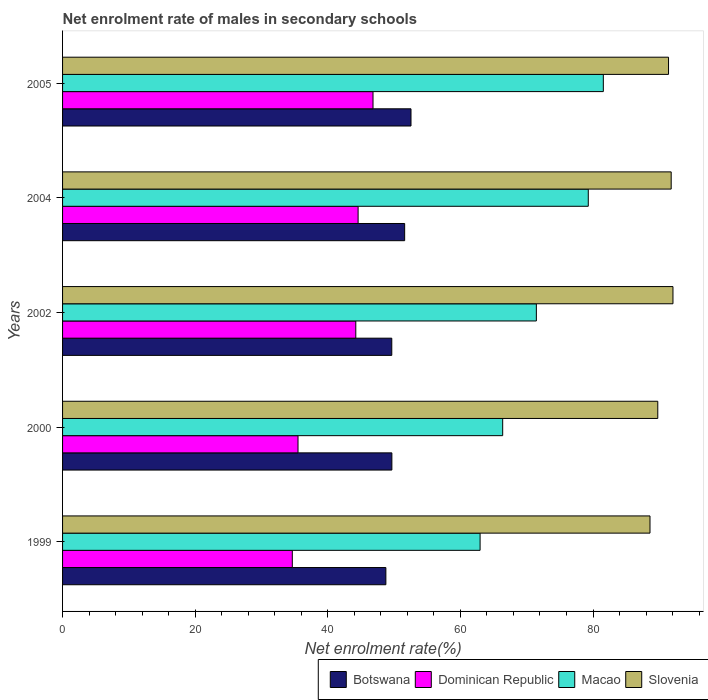Are the number of bars per tick equal to the number of legend labels?
Keep it short and to the point. Yes. How many bars are there on the 3rd tick from the top?
Give a very brief answer. 4. How many bars are there on the 2nd tick from the bottom?
Your response must be concise. 4. What is the label of the 1st group of bars from the top?
Offer a terse response. 2005. In how many cases, is the number of bars for a given year not equal to the number of legend labels?
Ensure brevity in your answer.  0. What is the net enrolment rate of males in secondary schools in Dominican Republic in 1999?
Provide a succinct answer. 34.65. Across all years, what is the maximum net enrolment rate of males in secondary schools in Macao?
Keep it short and to the point. 81.56. Across all years, what is the minimum net enrolment rate of males in secondary schools in Dominican Republic?
Provide a short and direct response. 34.65. In which year was the net enrolment rate of males in secondary schools in Slovenia minimum?
Your response must be concise. 1999. What is the total net enrolment rate of males in secondary schools in Dominican Republic in the graph?
Provide a succinct answer. 205.78. What is the difference between the net enrolment rate of males in secondary schools in Botswana in 2002 and that in 2004?
Your response must be concise. -1.94. What is the difference between the net enrolment rate of males in secondary schools in Botswana in 2000 and the net enrolment rate of males in secondary schools in Dominican Republic in 2002?
Provide a short and direct response. 5.44. What is the average net enrolment rate of males in secondary schools in Macao per year?
Your response must be concise. 72.33. In the year 2000, what is the difference between the net enrolment rate of males in secondary schools in Dominican Republic and net enrolment rate of males in secondary schools in Slovenia?
Your response must be concise. -54.26. What is the ratio of the net enrolment rate of males in secondary schools in Botswana in 1999 to that in 2000?
Your answer should be very brief. 0.98. Is the net enrolment rate of males in secondary schools in Macao in 2004 less than that in 2005?
Offer a very short reply. Yes. What is the difference between the highest and the second highest net enrolment rate of males in secondary schools in Slovenia?
Make the answer very short. 0.27. What is the difference between the highest and the lowest net enrolment rate of males in secondary schools in Slovenia?
Make the answer very short. 3.46. Is the sum of the net enrolment rate of males in secondary schools in Slovenia in 2004 and 2005 greater than the maximum net enrolment rate of males in secondary schools in Macao across all years?
Provide a succinct answer. Yes. What does the 2nd bar from the top in 2004 represents?
Provide a short and direct response. Macao. What does the 4th bar from the bottom in 2002 represents?
Keep it short and to the point. Slovenia. Are all the bars in the graph horizontal?
Your answer should be very brief. Yes. How many years are there in the graph?
Provide a succinct answer. 5. What is the difference between two consecutive major ticks on the X-axis?
Offer a very short reply. 20. Does the graph contain any zero values?
Your answer should be very brief. No. Where does the legend appear in the graph?
Give a very brief answer. Bottom right. What is the title of the graph?
Offer a very short reply. Net enrolment rate of males in secondary schools. What is the label or title of the X-axis?
Provide a short and direct response. Net enrolment rate(%). What is the label or title of the Y-axis?
Your response must be concise. Years. What is the Net enrolment rate(%) in Botswana in 1999?
Keep it short and to the point. 48.76. What is the Net enrolment rate(%) in Dominican Republic in 1999?
Ensure brevity in your answer.  34.65. What is the Net enrolment rate(%) of Macao in 1999?
Your answer should be compact. 62.97. What is the Net enrolment rate(%) of Slovenia in 1999?
Provide a short and direct response. 88.6. What is the Net enrolment rate(%) in Botswana in 2000?
Give a very brief answer. 49.67. What is the Net enrolment rate(%) of Dominican Republic in 2000?
Keep it short and to the point. 35.51. What is the Net enrolment rate(%) of Macao in 2000?
Make the answer very short. 66.38. What is the Net enrolment rate(%) in Slovenia in 2000?
Your response must be concise. 89.77. What is the Net enrolment rate(%) of Botswana in 2002?
Your answer should be very brief. 49.65. What is the Net enrolment rate(%) in Dominican Republic in 2002?
Your answer should be very brief. 44.22. What is the Net enrolment rate(%) of Macao in 2002?
Your response must be concise. 71.46. What is the Net enrolment rate(%) in Slovenia in 2002?
Provide a succinct answer. 92.06. What is the Net enrolment rate(%) of Botswana in 2004?
Keep it short and to the point. 51.59. What is the Net enrolment rate(%) of Dominican Republic in 2004?
Provide a short and direct response. 44.57. What is the Net enrolment rate(%) of Macao in 2004?
Ensure brevity in your answer.  79.29. What is the Net enrolment rate(%) in Slovenia in 2004?
Give a very brief answer. 91.79. What is the Net enrolment rate(%) of Botswana in 2005?
Offer a terse response. 52.55. What is the Net enrolment rate(%) in Dominican Republic in 2005?
Your response must be concise. 46.82. What is the Net enrolment rate(%) in Macao in 2005?
Your response must be concise. 81.56. What is the Net enrolment rate(%) in Slovenia in 2005?
Ensure brevity in your answer.  91.39. Across all years, what is the maximum Net enrolment rate(%) of Botswana?
Offer a terse response. 52.55. Across all years, what is the maximum Net enrolment rate(%) in Dominican Republic?
Provide a short and direct response. 46.82. Across all years, what is the maximum Net enrolment rate(%) of Macao?
Make the answer very short. 81.56. Across all years, what is the maximum Net enrolment rate(%) in Slovenia?
Keep it short and to the point. 92.06. Across all years, what is the minimum Net enrolment rate(%) of Botswana?
Make the answer very short. 48.76. Across all years, what is the minimum Net enrolment rate(%) of Dominican Republic?
Ensure brevity in your answer.  34.65. Across all years, what is the minimum Net enrolment rate(%) in Macao?
Make the answer very short. 62.97. Across all years, what is the minimum Net enrolment rate(%) of Slovenia?
Ensure brevity in your answer.  88.6. What is the total Net enrolment rate(%) of Botswana in the graph?
Provide a succinct answer. 252.22. What is the total Net enrolment rate(%) in Dominican Republic in the graph?
Offer a very short reply. 205.78. What is the total Net enrolment rate(%) of Macao in the graph?
Your response must be concise. 361.65. What is the total Net enrolment rate(%) of Slovenia in the graph?
Provide a short and direct response. 453.61. What is the difference between the Net enrolment rate(%) of Botswana in 1999 and that in 2000?
Offer a terse response. -0.9. What is the difference between the Net enrolment rate(%) of Dominican Republic in 1999 and that in 2000?
Your answer should be compact. -0.86. What is the difference between the Net enrolment rate(%) in Macao in 1999 and that in 2000?
Offer a very short reply. -3.41. What is the difference between the Net enrolment rate(%) in Slovenia in 1999 and that in 2000?
Provide a succinct answer. -1.17. What is the difference between the Net enrolment rate(%) of Botswana in 1999 and that in 2002?
Your response must be concise. -0.89. What is the difference between the Net enrolment rate(%) in Dominican Republic in 1999 and that in 2002?
Your response must be concise. -9.57. What is the difference between the Net enrolment rate(%) in Macao in 1999 and that in 2002?
Your answer should be compact. -8.49. What is the difference between the Net enrolment rate(%) of Slovenia in 1999 and that in 2002?
Provide a succinct answer. -3.46. What is the difference between the Net enrolment rate(%) of Botswana in 1999 and that in 2004?
Ensure brevity in your answer.  -2.83. What is the difference between the Net enrolment rate(%) of Dominican Republic in 1999 and that in 2004?
Keep it short and to the point. -9.92. What is the difference between the Net enrolment rate(%) in Macao in 1999 and that in 2004?
Provide a succinct answer. -16.32. What is the difference between the Net enrolment rate(%) in Slovenia in 1999 and that in 2004?
Keep it short and to the point. -3.2. What is the difference between the Net enrolment rate(%) in Botswana in 1999 and that in 2005?
Give a very brief answer. -3.79. What is the difference between the Net enrolment rate(%) in Dominican Republic in 1999 and that in 2005?
Give a very brief answer. -12.17. What is the difference between the Net enrolment rate(%) in Macao in 1999 and that in 2005?
Offer a very short reply. -18.59. What is the difference between the Net enrolment rate(%) in Slovenia in 1999 and that in 2005?
Give a very brief answer. -2.79. What is the difference between the Net enrolment rate(%) in Botswana in 2000 and that in 2002?
Give a very brief answer. 0.01. What is the difference between the Net enrolment rate(%) of Dominican Republic in 2000 and that in 2002?
Provide a short and direct response. -8.71. What is the difference between the Net enrolment rate(%) in Macao in 2000 and that in 2002?
Keep it short and to the point. -5.08. What is the difference between the Net enrolment rate(%) of Slovenia in 2000 and that in 2002?
Your response must be concise. -2.29. What is the difference between the Net enrolment rate(%) of Botswana in 2000 and that in 2004?
Offer a terse response. -1.93. What is the difference between the Net enrolment rate(%) in Dominican Republic in 2000 and that in 2004?
Give a very brief answer. -9.06. What is the difference between the Net enrolment rate(%) of Macao in 2000 and that in 2004?
Give a very brief answer. -12.91. What is the difference between the Net enrolment rate(%) of Slovenia in 2000 and that in 2004?
Your answer should be very brief. -2.02. What is the difference between the Net enrolment rate(%) of Botswana in 2000 and that in 2005?
Keep it short and to the point. -2.89. What is the difference between the Net enrolment rate(%) in Dominican Republic in 2000 and that in 2005?
Ensure brevity in your answer.  -11.31. What is the difference between the Net enrolment rate(%) of Macao in 2000 and that in 2005?
Your answer should be very brief. -15.18. What is the difference between the Net enrolment rate(%) in Slovenia in 2000 and that in 2005?
Give a very brief answer. -1.62. What is the difference between the Net enrolment rate(%) in Botswana in 2002 and that in 2004?
Make the answer very short. -1.94. What is the difference between the Net enrolment rate(%) in Dominican Republic in 2002 and that in 2004?
Provide a short and direct response. -0.35. What is the difference between the Net enrolment rate(%) of Macao in 2002 and that in 2004?
Your response must be concise. -7.83. What is the difference between the Net enrolment rate(%) in Slovenia in 2002 and that in 2004?
Provide a short and direct response. 0.27. What is the difference between the Net enrolment rate(%) of Botswana in 2002 and that in 2005?
Offer a terse response. -2.9. What is the difference between the Net enrolment rate(%) of Dominican Republic in 2002 and that in 2005?
Your response must be concise. -2.6. What is the difference between the Net enrolment rate(%) of Macao in 2002 and that in 2005?
Give a very brief answer. -10.1. What is the difference between the Net enrolment rate(%) in Slovenia in 2002 and that in 2005?
Keep it short and to the point. 0.67. What is the difference between the Net enrolment rate(%) of Botswana in 2004 and that in 2005?
Offer a very short reply. -0.96. What is the difference between the Net enrolment rate(%) in Dominican Republic in 2004 and that in 2005?
Your answer should be compact. -2.25. What is the difference between the Net enrolment rate(%) of Macao in 2004 and that in 2005?
Offer a very short reply. -2.27. What is the difference between the Net enrolment rate(%) of Slovenia in 2004 and that in 2005?
Make the answer very short. 0.4. What is the difference between the Net enrolment rate(%) in Botswana in 1999 and the Net enrolment rate(%) in Dominican Republic in 2000?
Your answer should be very brief. 13.25. What is the difference between the Net enrolment rate(%) of Botswana in 1999 and the Net enrolment rate(%) of Macao in 2000?
Make the answer very short. -17.62. What is the difference between the Net enrolment rate(%) in Botswana in 1999 and the Net enrolment rate(%) in Slovenia in 2000?
Your response must be concise. -41.01. What is the difference between the Net enrolment rate(%) in Dominican Republic in 1999 and the Net enrolment rate(%) in Macao in 2000?
Make the answer very short. -31.73. What is the difference between the Net enrolment rate(%) of Dominican Republic in 1999 and the Net enrolment rate(%) of Slovenia in 2000?
Your response must be concise. -55.12. What is the difference between the Net enrolment rate(%) of Macao in 1999 and the Net enrolment rate(%) of Slovenia in 2000?
Make the answer very short. -26.8. What is the difference between the Net enrolment rate(%) in Botswana in 1999 and the Net enrolment rate(%) in Dominican Republic in 2002?
Provide a succinct answer. 4.54. What is the difference between the Net enrolment rate(%) in Botswana in 1999 and the Net enrolment rate(%) in Macao in 2002?
Offer a very short reply. -22.7. What is the difference between the Net enrolment rate(%) of Botswana in 1999 and the Net enrolment rate(%) of Slovenia in 2002?
Your answer should be very brief. -43.3. What is the difference between the Net enrolment rate(%) in Dominican Republic in 1999 and the Net enrolment rate(%) in Macao in 2002?
Offer a terse response. -36.81. What is the difference between the Net enrolment rate(%) of Dominican Republic in 1999 and the Net enrolment rate(%) of Slovenia in 2002?
Make the answer very short. -57.41. What is the difference between the Net enrolment rate(%) of Macao in 1999 and the Net enrolment rate(%) of Slovenia in 2002?
Your answer should be compact. -29.09. What is the difference between the Net enrolment rate(%) of Botswana in 1999 and the Net enrolment rate(%) of Dominican Republic in 2004?
Offer a very short reply. 4.19. What is the difference between the Net enrolment rate(%) in Botswana in 1999 and the Net enrolment rate(%) in Macao in 2004?
Your response must be concise. -30.53. What is the difference between the Net enrolment rate(%) of Botswana in 1999 and the Net enrolment rate(%) of Slovenia in 2004?
Ensure brevity in your answer.  -43.03. What is the difference between the Net enrolment rate(%) in Dominican Republic in 1999 and the Net enrolment rate(%) in Macao in 2004?
Offer a very short reply. -44.64. What is the difference between the Net enrolment rate(%) of Dominican Republic in 1999 and the Net enrolment rate(%) of Slovenia in 2004?
Keep it short and to the point. -57.14. What is the difference between the Net enrolment rate(%) in Macao in 1999 and the Net enrolment rate(%) in Slovenia in 2004?
Provide a succinct answer. -28.82. What is the difference between the Net enrolment rate(%) of Botswana in 1999 and the Net enrolment rate(%) of Dominican Republic in 2005?
Keep it short and to the point. 1.94. What is the difference between the Net enrolment rate(%) of Botswana in 1999 and the Net enrolment rate(%) of Macao in 2005?
Give a very brief answer. -32.79. What is the difference between the Net enrolment rate(%) of Botswana in 1999 and the Net enrolment rate(%) of Slovenia in 2005?
Give a very brief answer. -42.63. What is the difference between the Net enrolment rate(%) in Dominican Republic in 1999 and the Net enrolment rate(%) in Macao in 2005?
Provide a succinct answer. -46.91. What is the difference between the Net enrolment rate(%) in Dominican Republic in 1999 and the Net enrolment rate(%) in Slovenia in 2005?
Give a very brief answer. -56.74. What is the difference between the Net enrolment rate(%) of Macao in 1999 and the Net enrolment rate(%) of Slovenia in 2005?
Your answer should be compact. -28.42. What is the difference between the Net enrolment rate(%) of Botswana in 2000 and the Net enrolment rate(%) of Dominican Republic in 2002?
Provide a succinct answer. 5.44. What is the difference between the Net enrolment rate(%) in Botswana in 2000 and the Net enrolment rate(%) in Macao in 2002?
Make the answer very short. -21.79. What is the difference between the Net enrolment rate(%) in Botswana in 2000 and the Net enrolment rate(%) in Slovenia in 2002?
Ensure brevity in your answer.  -42.4. What is the difference between the Net enrolment rate(%) in Dominican Republic in 2000 and the Net enrolment rate(%) in Macao in 2002?
Make the answer very short. -35.95. What is the difference between the Net enrolment rate(%) in Dominican Republic in 2000 and the Net enrolment rate(%) in Slovenia in 2002?
Make the answer very short. -56.55. What is the difference between the Net enrolment rate(%) in Macao in 2000 and the Net enrolment rate(%) in Slovenia in 2002?
Offer a very short reply. -25.68. What is the difference between the Net enrolment rate(%) of Botswana in 2000 and the Net enrolment rate(%) of Dominican Republic in 2004?
Your answer should be very brief. 5.09. What is the difference between the Net enrolment rate(%) of Botswana in 2000 and the Net enrolment rate(%) of Macao in 2004?
Your answer should be very brief. -29.62. What is the difference between the Net enrolment rate(%) of Botswana in 2000 and the Net enrolment rate(%) of Slovenia in 2004?
Ensure brevity in your answer.  -42.13. What is the difference between the Net enrolment rate(%) in Dominican Republic in 2000 and the Net enrolment rate(%) in Macao in 2004?
Your answer should be very brief. -43.78. What is the difference between the Net enrolment rate(%) of Dominican Republic in 2000 and the Net enrolment rate(%) of Slovenia in 2004?
Make the answer very short. -56.28. What is the difference between the Net enrolment rate(%) in Macao in 2000 and the Net enrolment rate(%) in Slovenia in 2004?
Your response must be concise. -25.41. What is the difference between the Net enrolment rate(%) in Botswana in 2000 and the Net enrolment rate(%) in Dominican Republic in 2005?
Keep it short and to the point. 2.84. What is the difference between the Net enrolment rate(%) of Botswana in 2000 and the Net enrolment rate(%) of Macao in 2005?
Provide a short and direct response. -31.89. What is the difference between the Net enrolment rate(%) in Botswana in 2000 and the Net enrolment rate(%) in Slovenia in 2005?
Offer a very short reply. -41.73. What is the difference between the Net enrolment rate(%) of Dominican Republic in 2000 and the Net enrolment rate(%) of Macao in 2005?
Keep it short and to the point. -46.05. What is the difference between the Net enrolment rate(%) in Dominican Republic in 2000 and the Net enrolment rate(%) in Slovenia in 2005?
Give a very brief answer. -55.88. What is the difference between the Net enrolment rate(%) in Macao in 2000 and the Net enrolment rate(%) in Slovenia in 2005?
Keep it short and to the point. -25.01. What is the difference between the Net enrolment rate(%) of Botswana in 2002 and the Net enrolment rate(%) of Dominican Republic in 2004?
Your answer should be very brief. 5.08. What is the difference between the Net enrolment rate(%) of Botswana in 2002 and the Net enrolment rate(%) of Macao in 2004?
Make the answer very short. -29.64. What is the difference between the Net enrolment rate(%) of Botswana in 2002 and the Net enrolment rate(%) of Slovenia in 2004?
Provide a succinct answer. -42.14. What is the difference between the Net enrolment rate(%) of Dominican Republic in 2002 and the Net enrolment rate(%) of Macao in 2004?
Make the answer very short. -35.06. What is the difference between the Net enrolment rate(%) of Dominican Republic in 2002 and the Net enrolment rate(%) of Slovenia in 2004?
Make the answer very short. -47.57. What is the difference between the Net enrolment rate(%) of Macao in 2002 and the Net enrolment rate(%) of Slovenia in 2004?
Give a very brief answer. -20.34. What is the difference between the Net enrolment rate(%) in Botswana in 2002 and the Net enrolment rate(%) in Dominican Republic in 2005?
Keep it short and to the point. 2.83. What is the difference between the Net enrolment rate(%) of Botswana in 2002 and the Net enrolment rate(%) of Macao in 2005?
Your response must be concise. -31.91. What is the difference between the Net enrolment rate(%) of Botswana in 2002 and the Net enrolment rate(%) of Slovenia in 2005?
Your answer should be very brief. -41.74. What is the difference between the Net enrolment rate(%) in Dominican Republic in 2002 and the Net enrolment rate(%) in Macao in 2005?
Your answer should be compact. -37.33. What is the difference between the Net enrolment rate(%) in Dominican Republic in 2002 and the Net enrolment rate(%) in Slovenia in 2005?
Offer a very short reply. -47.17. What is the difference between the Net enrolment rate(%) in Macao in 2002 and the Net enrolment rate(%) in Slovenia in 2005?
Offer a terse response. -19.93. What is the difference between the Net enrolment rate(%) of Botswana in 2004 and the Net enrolment rate(%) of Dominican Republic in 2005?
Ensure brevity in your answer.  4.77. What is the difference between the Net enrolment rate(%) of Botswana in 2004 and the Net enrolment rate(%) of Macao in 2005?
Offer a terse response. -29.96. What is the difference between the Net enrolment rate(%) of Botswana in 2004 and the Net enrolment rate(%) of Slovenia in 2005?
Keep it short and to the point. -39.8. What is the difference between the Net enrolment rate(%) of Dominican Republic in 2004 and the Net enrolment rate(%) of Macao in 2005?
Offer a very short reply. -36.98. What is the difference between the Net enrolment rate(%) in Dominican Republic in 2004 and the Net enrolment rate(%) in Slovenia in 2005?
Provide a short and direct response. -46.82. What is the difference between the Net enrolment rate(%) of Macao in 2004 and the Net enrolment rate(%) of Slovenia in 2005?
Your answer should be very brief. -12.1. What is the average Net enrolment rate(%) of Botswana per year?
Give a very brief answer. 50.44. What is the average Net enrolment rate(%) in Dominican Republic per year?
Keep it short and to the point. 41.16. What is the average Net enrolment rate(%) of Macao per year?
Keep it short and to the point. 72.33. What is the average Net enrolment rate(%) of Slovenia per year?
Your answer should be compact. 90.72. In the year 1999, what is the difference between the Net enrolment rate(%) of Botswana and Net enrolment rate(%) of Dominican Republic?
Ensure brevity in your answer.  14.11. In the year 1999, what is the difference between the Net enrolment rate(%) of Botswana and Net enrolment rate(%) of Macao?
Your response must be concise. -14.21. In the year 1999, what is the difference between the Net enrolment rate(%) of Botswana and Net enrolment rate(%) of Slovenia?
Your answer should be compact. -39.83. In the year 1999, what is the difference between the Net enrolment rate(%) in Dominican Republic and Net enrolment rate(%) in Macao?
Make the answer very short. -28.32. In the year 1999, what is the difference between the Net enrolment rate(%) of Dominican Republic and Net enrolment rate(%) of Slovenia?
Your response must be concise. -53.95. In the year 1999, what is the difference between the Net enrolment rate(%) of Macao and Net enrolment rate(%) of Slovenia?
Your answer should be very brief. -25.63. In the year 2000, what is the difference between the Net enrolment rate(%) in Botswana and Net enrolment rate(%) in Dominican Republic?
Make the answer very short. 14.15. In the year 2000, what is the difference between the Net enrolment rate(%) of Botswana and Net enrolment rate(%) of Macao?
Your answer should be very brief. -16.71. In the year 2000, what is the difference between the Net enrolment rate(%) of Botswana and Net enrolment rate(%) of Slovenia?
Give a very brief answer. -40.11. In the year 2000, what is the difference between the Net enrolment rate(%) in Dominican Republic and Net enrolment rate(%) in Macao?
Keep it short and to the point. -30.87. In the year 2000, what is the difference between the Net enrolment rate(%) of Dominican Republic and Net enrolment rate(%) of Slovenia?
Provide a short and direct response. -54.26. In the year 2000, what is the difference between the Net enrolment rate(%) in Macao and Net enrolment rate(%) in Slovenia?
Provide a short and direct response. -23.39. In the year 2002, what is the difference between the Net enrolment rate(%) of Botswana and Net enrolment rate(%) of Dominican Republic?
Your response must be concise. 5.43. In the year 2002, what is the difference between the Net enrolment rate(%) of Botswana and Net enrolment rate(%) of Macao?
Offer a very short reply. -21.81. In the year 2002, what is the difference between the Net enrolment rate(%) in Botswana and Net enrolment rate(%) in Slovenia?
Ensure brevity in your answer.  -42.41. In the year 2002, what is the difference between the Net enrolment rate(%) of Dominican Republic and Net enrolment rate(%) of Macao?
Keep it short and to the point. -27.23. In the year 2002, what is the difference between the Net enrolment rate(%) in Dominican Republic and Net enrolment rate(%) in Slovenia?
Make the answer very short. -47.84. In the year 2002, what is the difference between the Net enrolment rate(%) of Macao and Net enrolment rate(%) of Slovenia?
Give a very brief answer. -20.6. In the year 2004, what is the difference between the Net enrolment rate(%) of Botswana and Net enrolment rate(%) of Dominican Republic?
Provide a succinct answer. 7.02. In the year 2004, what is the difference between the Net enrolment rate(%) of Botswana and Net enrolment rate(%) of Macao?
Your answer should be very brief. -27.7. In the year 2004, what is the difference between the Net enrolment rate(%) in Botswana and Net enrolment rate(%) in Slovenia?
Offer a terse response. -40.2. In the year 2004, what is the difference between the Net enrolment rate(%) in Dominican Republic and Net enrolment rate(%) in Macao?
Give a very brief answer. -34.72. In the year 2004, what is the difference between the Net enrolment rate(%) in Dominican Republic and Net enrolment rate(%) in Slovenia?
Provide a short and direct response. -47.22. In the year 2004, what is the difference between the Net enrolment rate(%) of Macao and Net enrolment rate(%) of Slovenia?
Ensure brevity in your answer.  -12.5. In the year 2005, what is the difference between the Net enrolment rate(%) in Botswana and Net enrolment rate(%) in Dominican Republic?
Provide a succinct answer. 5.73. In the year 2005, what is the difference between the Net enrolment rate(%) in Botswana and Net enrolment rate(%) in Macao?
Offer a very short reply. -29.01. In the year 2005, what is the difference between the Net enrolment rate(%) of Botswana and Net enrolment rate(%) of Slovenia?
Your answer should be very brief. -38.84. In the year 2005, what is the difference between the Net enrolment rate(%) in Dominican Republic and Net enrolment rate(%) in Macao?
Provide a short and direct response. -34.73. In the year 2005, what is the difference between the Net enrolment rate(%) of Dominican Republic and Net enrolment rate(%) of Slovenia?
Ensure brevity in your answer.  -44.57. In the year 2005, what is the difference between the Net enrolment rate(%) in Macao and Net enrolment rate(%) in Slovenia?
Offer a terse response. -9.83. What is the ratio of the Net enrolment rate(%) in Botswana in 1999 to that in 2000?
Ensure brevity in your answer.  0.98. What is the ratio of the Net enrolment rate(%) in Dominican Republic in 1999 to that in 2000?
Make the answer very short. 0.98. What is the ratio of the Net enrolment rate(%) in Macao in 1999 to that in 2000?
Your response must be concise. 0.95. What is the ratio of the Net enrolment rate(%) of Slovenia in 1999 to that in 2000?
Give a very brief answer. 0.99. What is the ratio of the Net enrolment rate(%) of Botswana in 1999 to that in 2002?
Keep it short and to the point. 0.98. What is the ratio of the Net enrolment rate(%) of Dominican Republic in 1999 to that in 2002?
Provide a succinct answer. 0.78. What is the ratio of the Net enrolment rate(%) in Macao in 1999 to that in 2002?
Your answer should be very brief. 0.88. What is the ratio of the Net enrolment rate(%) in Slovenia in 1999 to that in 2002?
Your answer should be very brief. 0.96. What is the ratio of the Net enrolment rate(%) in Botswana in 1999 to that in 2004?
Offer a terse response. 0.95. What is the ratio of the Net enrolment rate(%) in Dominican Republic in 1999 to that in 2004?
Provide a succinct answer. 0.78. What is the ratio of the Net enrolment rate(%) of Macao in 1999 to that in 2004?
Offer a terse response. 0.79. What is the ratio of the Net enrolment rate(%) in Slovenia in 1999 to that in 2004?
Your answer should be very brief. 0.97. What is the ratio of the Net enrolment rate(%) of Botswana in 1999 to that in 2005?
Your answer should be very brief. 0.93. What is the ratio of the Net enrolment rate(%) of Dominican Republic in 1999 to that in 2005?
Offer a very short reply. 0.74. What is the ratio of the Net enrolment rate(%) of Macao in 1999 to that in 2005?
Provide a succinct answer. 0.77. What is the ratio of the Net enrolment rate(%) in Slovenia in 1999 to that in 2005?
Provide a succinct answer. 0.97. What is the ratio of the Net enrolment rate(%) of Botswana in 2000 to that in 2002?
Provide a succinct answer. 1. What is the ratio of the Net enrolment rate(%) of Dominican Republic in 2000 to that in 2002?
Ensure brevity in your answer.  0.8. What is the ratio of the Net enrolment rate(%) of Macao in 2000 to that in 2002?
Keep it short and to the point. 0.93. What is the ratio of the Net enrolment rate(%) of Slovenia in 2000 to that in 2002?
Your response must be concise. 0.98. What is the ratio of the Net enrolment rate(%) of Botswana in 2000 to that in 2004?
Give a very brief answer. 0.96. What is the ratio of the Net enrolment rate(%) in Dominican Republic in 2000 to that in 2004?
Give a very brief answer. 0.8. What is the ratio of the Net enrolment rate(%) in Macao in 2000 to that in 2004?
Offer a very short reply. 0.84. What is the ratio of the Net enrolment rate(%) in Slovenia in 2000 to that in 2004?
Keep it short and to the point. 0.98. What is the ratio of the Net enrolment rate(%) of Botswana in 2000 to that in 2005?
Keep it short and to the point. 0.95. What is the ratio of the Net enrolment rate(%) of Dominican Republic in 2000 to that in 2005?
Make the answer very short. 0.76. What is the ratio of the Net enrolment rate(%) of Macao in 2000 to that in 2005?
Your answer should be compact. 0.81. What is the ratio of the Net enrolment rate(%) of Slovenia in 2000 to that in 2005?
Give a very brief answer. 0.98. What is the ratio of the Net enrolment rate(%) in Botswana in 2002 to that in 2004?
Ensure brevity in your answer.  0.96. What is the ratio of the Net enrolment rate(%) in Macao in 2002 to that in 2004?
Offer a terse response. 0.9. What is the ratio of the Net enrolment rate(%) of Slovenia in 2002 to that in 2004?
Provide a succinct answer. 1. What is the ratio of the Net enrolment rate(%) of Botswana in 2002 to that in 2005?
Ensure brevity in your answer.  0.94. What is the ratio of the Net enrolment rate(%) of Dominican Republic in 2002 to that in 2005?
Your answer should be very brief. 0.94. What is the ratio of the Net enrolment rate(%) of Macao in 2002 to that in 2005?
Your response must be concise. 0.88. What is the ratio of the Net enrolment rate(%) of Slovenia in 2002 to that in 2005?
Your answer should be compact. 1.01. What is the ratio of the Net enrolment rate(%) in Botswana in 2004 to that in 2005?
Provide a succinct answer. 0.98. What is the ratio of the Net enrolment rate(%) in Dominican Republic in 2004 to that in 2005?
Your answer should be very brief. 0.95. What is the ratio of the Net enrolment rate(%) in Macao in 2004 to that in 2005?
Ensure brevity in your answer.  0.97. What is the difference between the highest and the second highest Net enrolment rate(%) of Botswana?
Make the answer very short. 0.96. What is the difference between the highest and the second highest Net enrolment rate(%) of Dominican Republic?
Give a very brief answer. 2.25. What is the difference between the highest and the second highest Net enrolment rate(%) in Macao?
Your answer should be compact. 2.27. What is the difference between the highest and the second highest Net enrolment rate(%) in Slovenia?
Your response must be concise. 0.27. What is the difference between the highest and the lowest Net enrolment rate(%) of Botswana?
Keep it short and to the point. 3.79. What is the difference between the highest and the lowest Net enrolment rate(%) of Dominican Republic?
Your answer should be compact. 12.17. What is the difference between the highest and the lowest Net enrolment rate(%) in Macao?
Offer a terse response. 18.59. What is the difference between the highest and the lowest Net enrolment rate(%) of Slovenia?
Give a very brief answer. 3.46. 